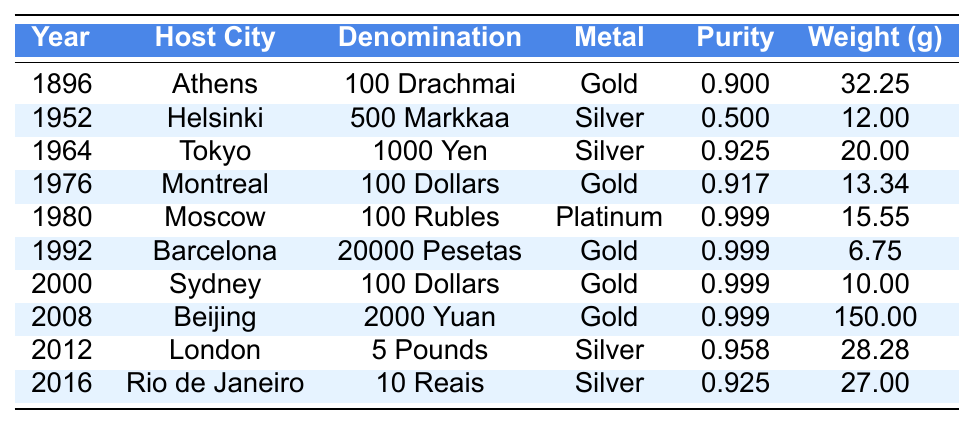What is the metal composition of the coin from the year 1980? The table lists the coin from 1980 as being made of Platinum.
Answer: Platinum Which Olympic coin has the highest purity? By checking the table, the 2008 Beijing coin, made of Gold, has a purity of 0.999, which is the highest among all listed coins.
Answer: 0.999 How many coins are made of Silver? The table indicates that there are four coins made of Silver (1952, 1964, 2012, and 2016).
Answer: 4 What is the total weight of all Gold coins listed in the table? The weights of Gold coins are: 32.25g (1896) + 13.34g (1976) + 6.75g (1992) + 10.00g (2000) + 150.00g (2008) = 212.34g.
Answer: 212.34 grams Did any Olympic coin have a purity of 0.500? Looking through the table, I find the 1952 Helsinki coin has a purity of 0.500, confirming that yes, one does exist.
Answer: Yes Which host city corresponds to the coin with the lowest weight? The 1992 Barcelona coin weighs 6.75 grams and is the least heavy; therefore, Barcelona is the host city.
Answer: Barcelona What is the average weight of all coins made of Silver? The Silver coins weigh: 12.00g (1952), 20.00g (1964), 28.28g (2012), and 27.00g (2016). The total is 12.00 + 20.00 + 28.28 + 27.00 = 87.28g. Dividing by 4 gives an average weight of 21.82 grams.
Answer: 21.82 grams How many coins were minted in the 2000s? The table shows there are three coins minted in the 2000s (2000, 2008, and 2012).
Answer: 3 Is there a coin from Tokyo, and if so, what is its purity? The table has the 1964 Tokyo coin, and its purity is 0.925.
Answer: Yes, 0.925 What is the difference in purity between the Gold coin from 2008 and the Silver coin from 2016? The 2008 Gold coin has a purity of 0.999, while the 2016 Silver coin has a purity of 0.925. The difference is 0.999 - 0.925 = 0.074.
Answer: 0.074 